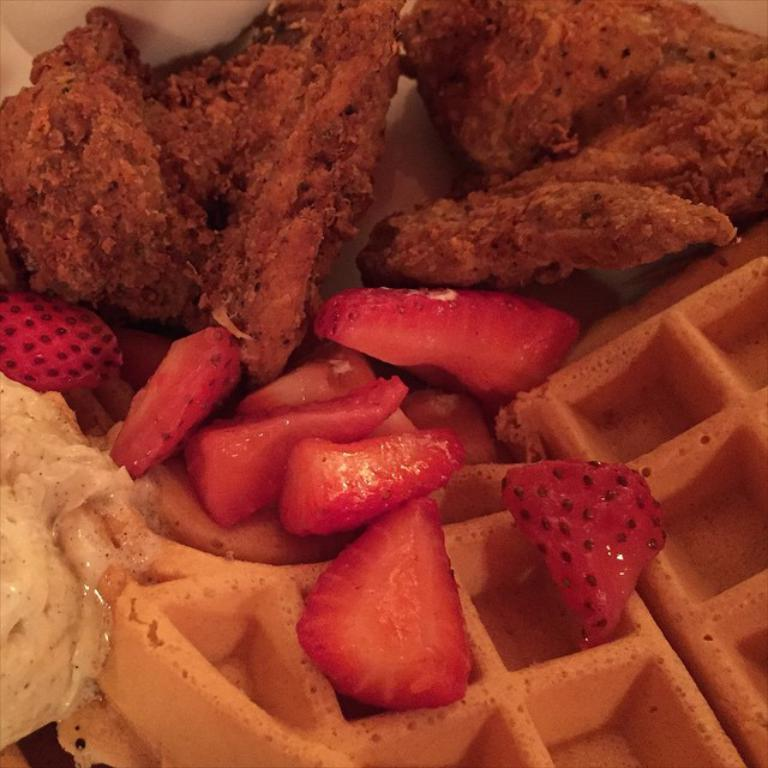What type of food can be seen in the image? There are waffles and strawberry slices in the image. Are there any other food items visible in the image? Yes, there are other food items in the image. Can you describe the amusement park in the image? There is no amusement park present in the image; it features food items such as waffles and strawberry slices. How many giants are visible in the image? There are no giants present in the image. 